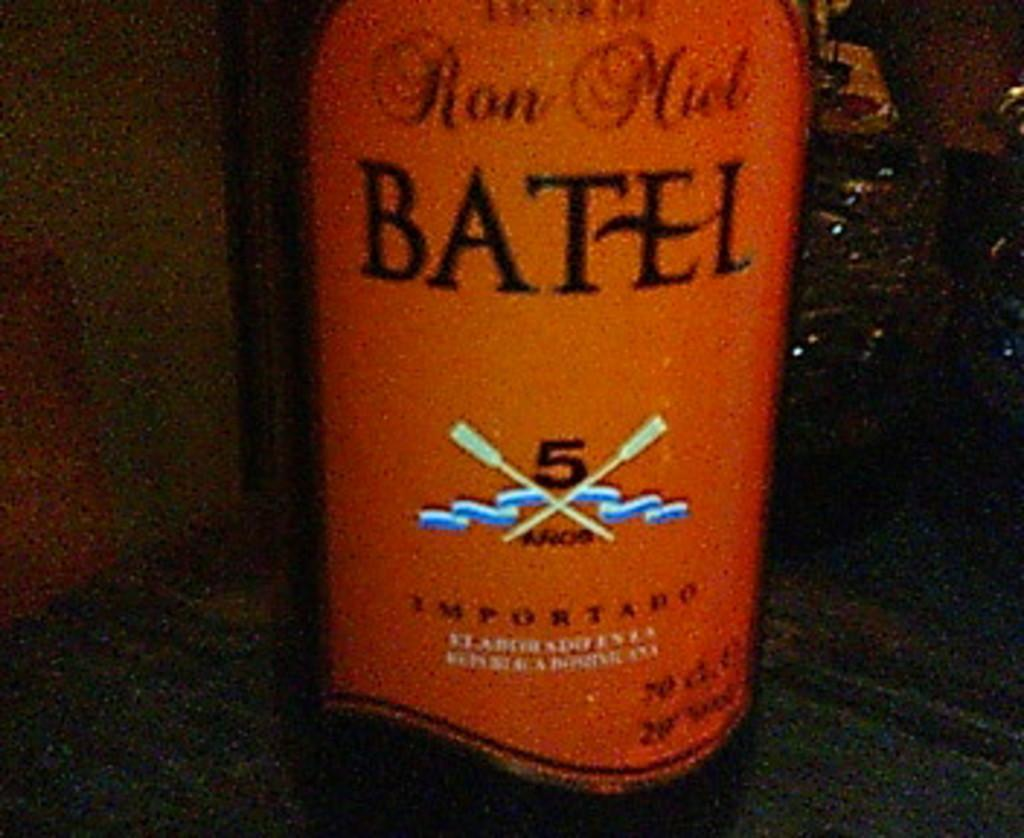<image>
Offer a succinct explanation of the picture presented. A bottle of Ron Miel Batel has a orange label. 